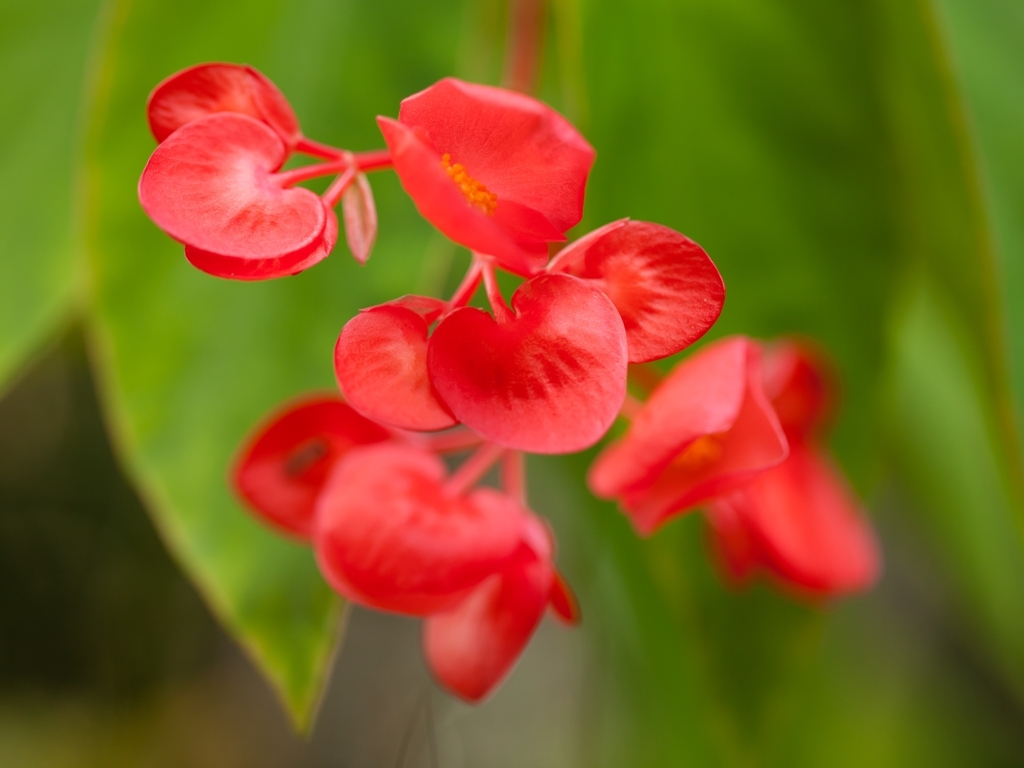Can you tell me more about the type of flower shown in this image and where it is commonly found? The flower in the image looks like a variety of Euphorbia milii, commonly known as the Crown of Thorns. It's a tropical plant, native to Madagascar and found in warm climates worldwide. Its striking red or pink bracts make it quite popular in ornamental gardening. 